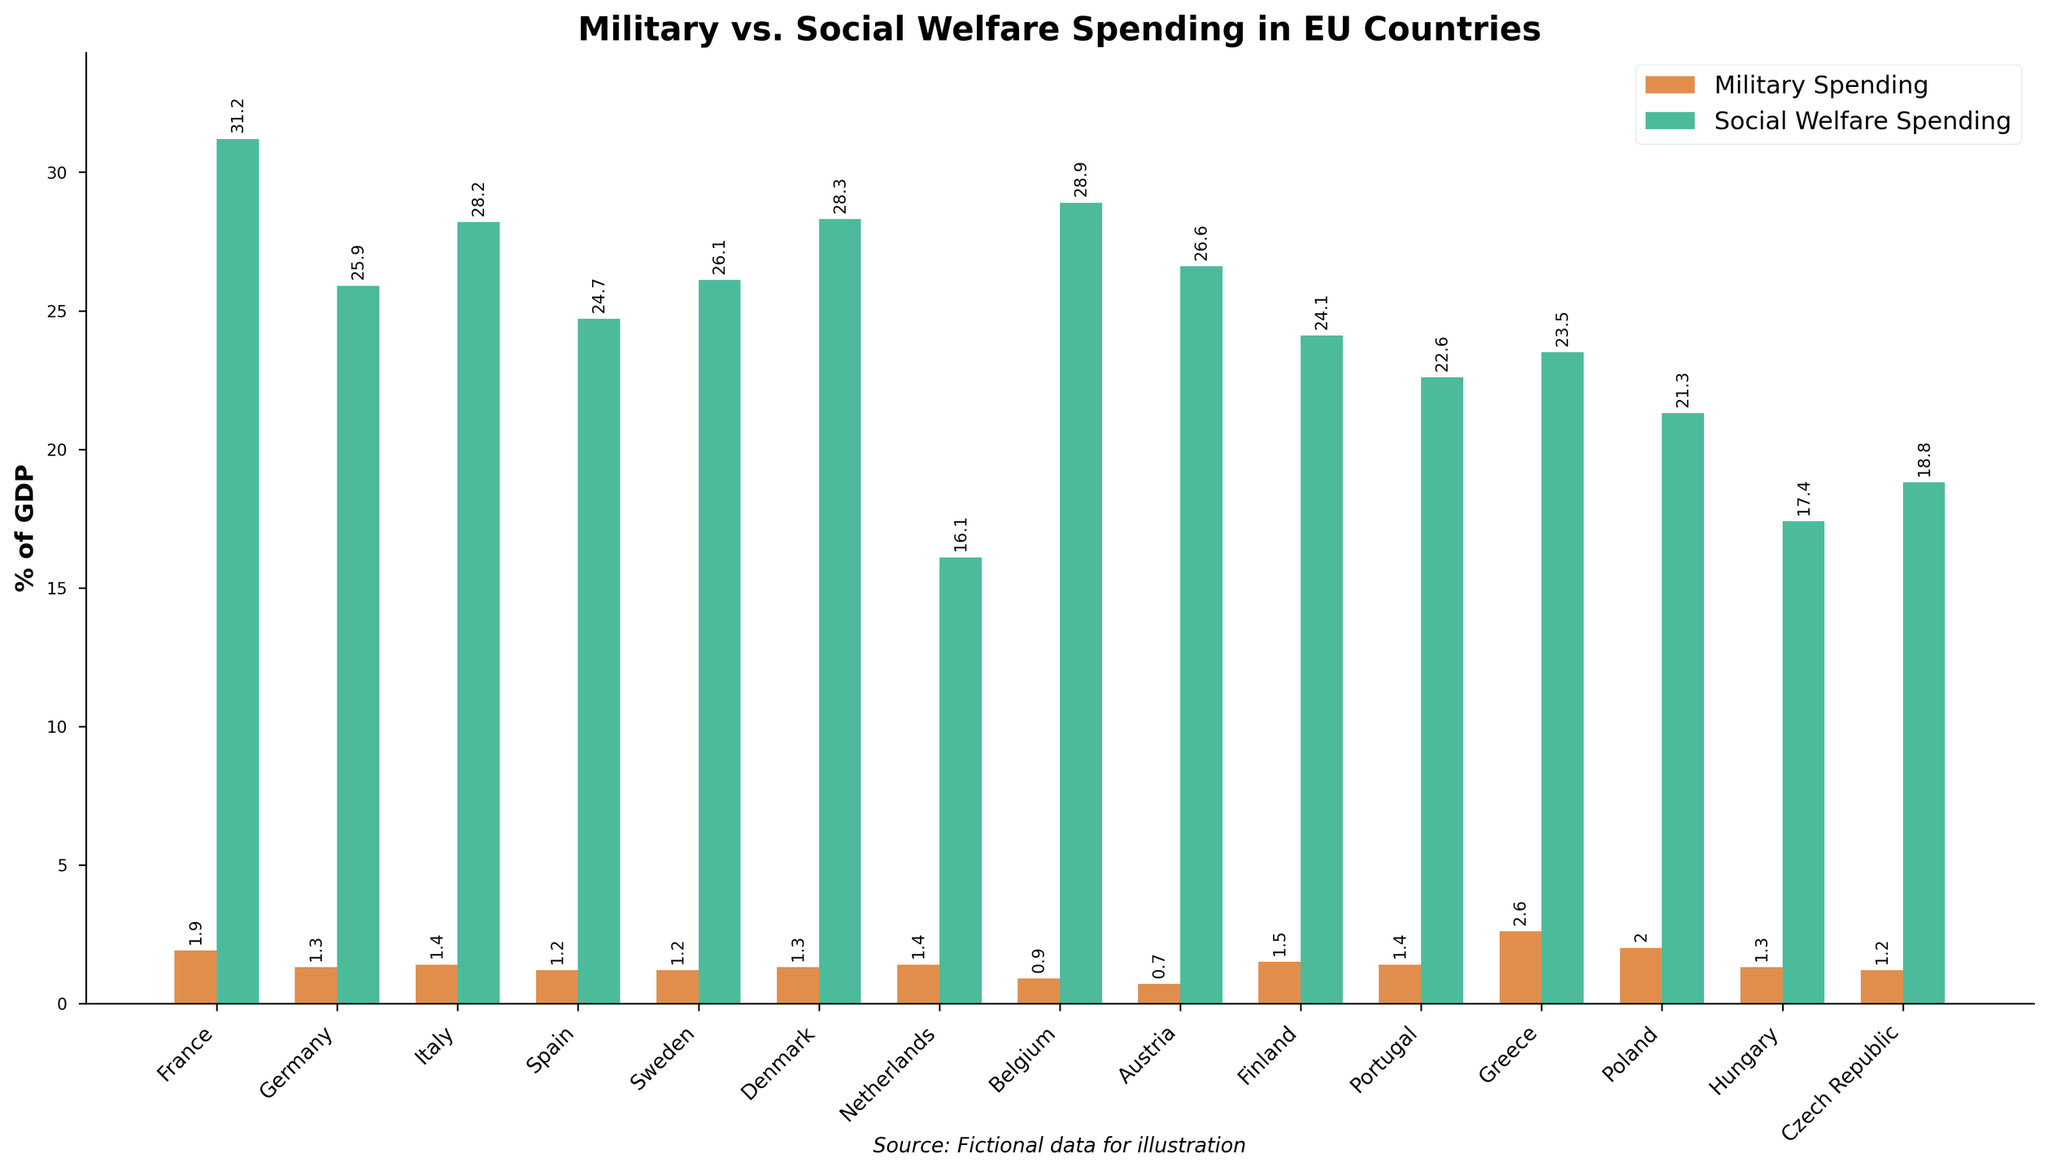Which country has the highest military spending as a percentage of GDP? Look at the bar representing military spending for each country. The tallest bar corresponds to the highest percentage. Here, Greece has the tallest red bar.
Answer: Greece Which two countries have the closest levels of military spending as a percentage of GDP? Compare the heights of the red bars to find two that are approximately the same height. France and Poland have red bars of similar height.
Answer: France and Poland What's the difference between military and social welfare spending in Spain? Identify the heights of the red and green bars for Spain, then calculate the difference. Military Spending: 1.2%, Social Welfare Spending: 24.7%, Difference: 24.7% - 1.2%
Answer: 23.5% Which country has the greatest discrepancy between military spending and social welfare spending? Calculate the difference between red and green bars for each country and identify the maximum difference. France has the largest difference.
Answer: France What's the average military spending as a percentage of GDP in the listed countries? Sum all military spending percentages and divide by the number of countries. Total Military Spending = 1.9 + 1.3 + 1.4 + 1.2 + 1.2 + 1.3 + 1.4 + 0.9 + 0.7 + 1.5 + 1.4 + 2.6 + 2.0 + 1.3 + 1.2 = 22.3. Average = 22.3 / 15
Answer: 1.49% Are there any countries with equal military and social welfare spending percentages? Compare red and green bars for each country; none of the countries have equal-sized bars.
Answer: No How does Denmark compare to Sweden in terms of social welfare spending? Look at the green bars for Denmark and Sweden and compare their heights. Denmark’s green bar is higher.
Answer: Denmark has higher social welfare spending Which three countries have military spending above 2% of their GDP? Identify the red bars above 2%. Greece, Poland, and France have military spending above 2% of GDP.
Answer: Greece, Poland, and France What’s the total social welfare spending percentage for Germany and Italy? Add the green bar heights for Germany (25.9%) and Italy (28.2%) to get the combined total. 25.9 + 28.2 = 54.1
Answer: 54.1% How does the ratio of social welfare to military spending in Austria compare to that in Poland? Calculate the ratios: Austria’s Social Welfare (26.6%)/Military (0.7%) and Poland’s Social Welfare (21.3%)/Military (2.0%). Ratios: Austria = 38, Poland = 10.65
Answer: Austria's ratio is higher 